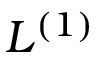Convert formula to latex. <formula><loc_0><loc_0><loc_500><loc_500>L ^ { ( 1 ) }</formula> 